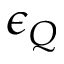Convert formula to latex. <formula><loc_0><loc_0><loc_500><loc_500>\epsilon _ { Q }</formula> 